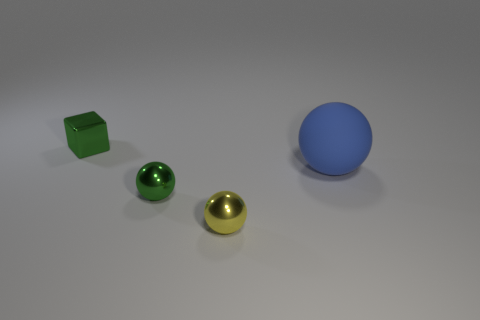There is a ball that is the same color as the tiny metal cube; what is it made of?
Your response must be concise. Metal. What size is the ball that is the same color as the metal cube?
Provide a short and direct response. Small. The yellow object that is made of the same material as the small green cube is what shape?
Offer a terse response. Sphere. Is there anything else that has the same color as the big thing?
Offer a terse response. No. Is the number of tiny yellow shiny spheres that are right of the yellow metallic sphere greater than the number of large balls?
Give a very brief answer. No. What is the small yellow ball made of?
Offer a terse response. Metal. How many red metal balls have the same size as the yellow thing?
Offer a terse response. 0. Are there the same number of metallic cubes right of the green ball and green metal balls in front of the rubber ball?
Ensure brevity in your answer.  No. Does the tiny cube have the same material as the tiny green ball?
Your answer should be very brief. Yes. Is there a large blue object behind the tiny green metallic object that is behind the large blue object?
Provide a succinct answer. No. 